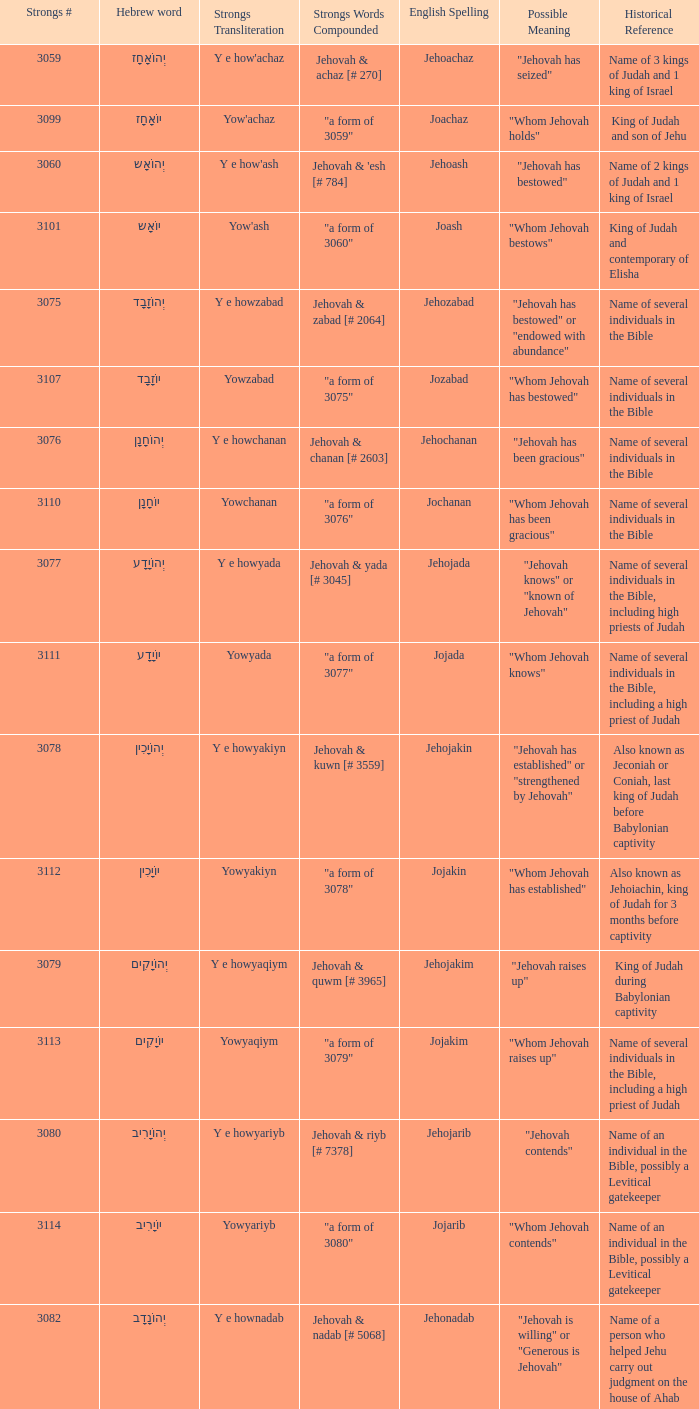How many strongs transliteration of the english spelling of the work jehojakin? 1.0. 